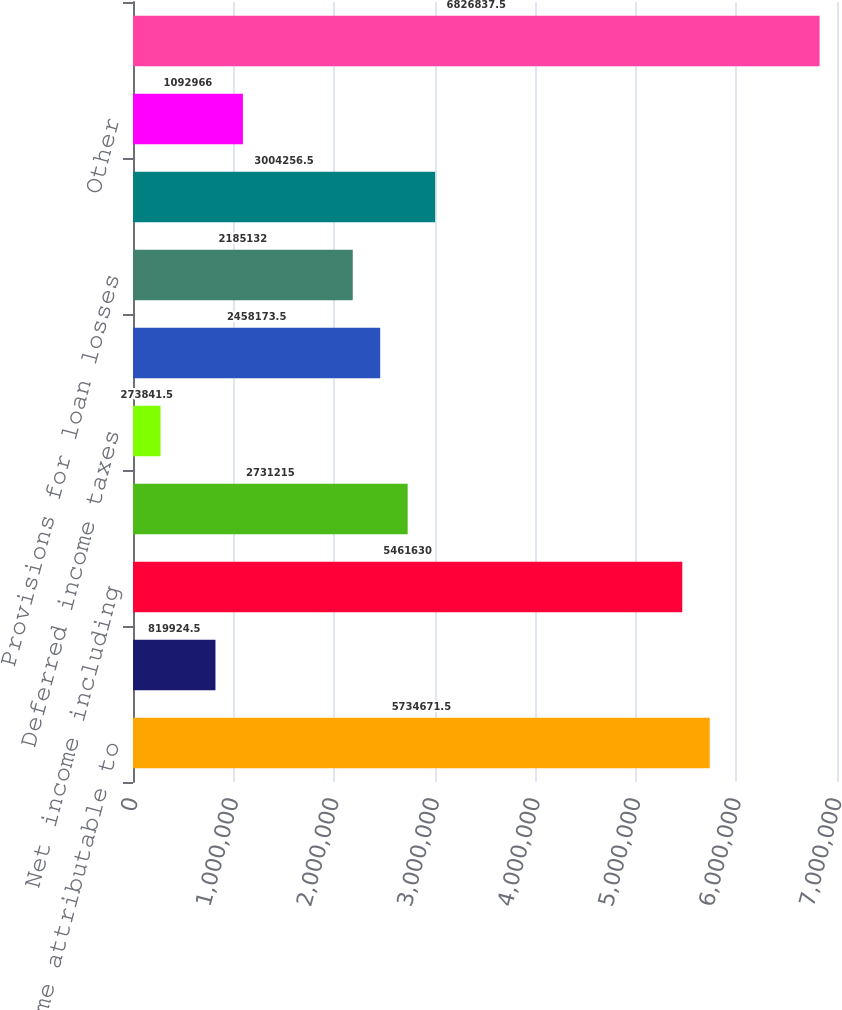Convert chart to OTSL. <chart><loc_0><loc_0><loc_500><loc_500><bar_chart><fcel>Net income attributable to<fcel>Net loss attributable to<fcel>Net income including<fcel>Depreciation and amortization<fcel>Deferred income taxes<fcel>Premium and discount<fcel>Provisions for loan losses<fcel>Share-based compensation<fcel>Other<fcel>Assets segregated pursuant to<nl><fcel>5.73467e+06<fcel>819924<fcel>5.46163e+06<fcel>2.73122e+06<fcel>273842<fcel>2.45817e+06<fcel>2.18513e+06<fcel>3.00426e+06<fcel>1.09297e+06<fcel>6.82684e+06<nl></chart> 